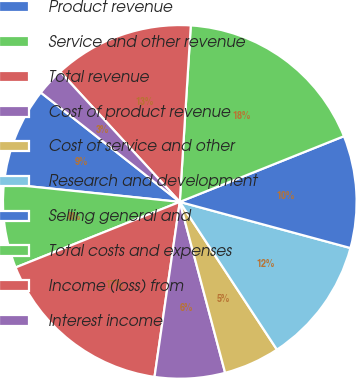Convert chart. <chart><loc_0><loc_0><loc_500><loc_500><pie_chart><fcel>Product revenue<fcel>Service and other revenue<fcel>Total revenue<fcel>Cost of product revenue<fcel>Cost of service and other<fcel>Research and development<fcel>Selling general and<fcel>Total costs and expenses<fcel>Income (loss) from<fcel>Interest income<nl><fcel>8.97%<fcel>7.69%<fcel>16.67%<fcel>6.41%<fcel>5.13%<fcel>11.54%<fcel>10.26%<fcel>17.95%<fcel>12.82%<fcel>2.56%<nl></chart> 